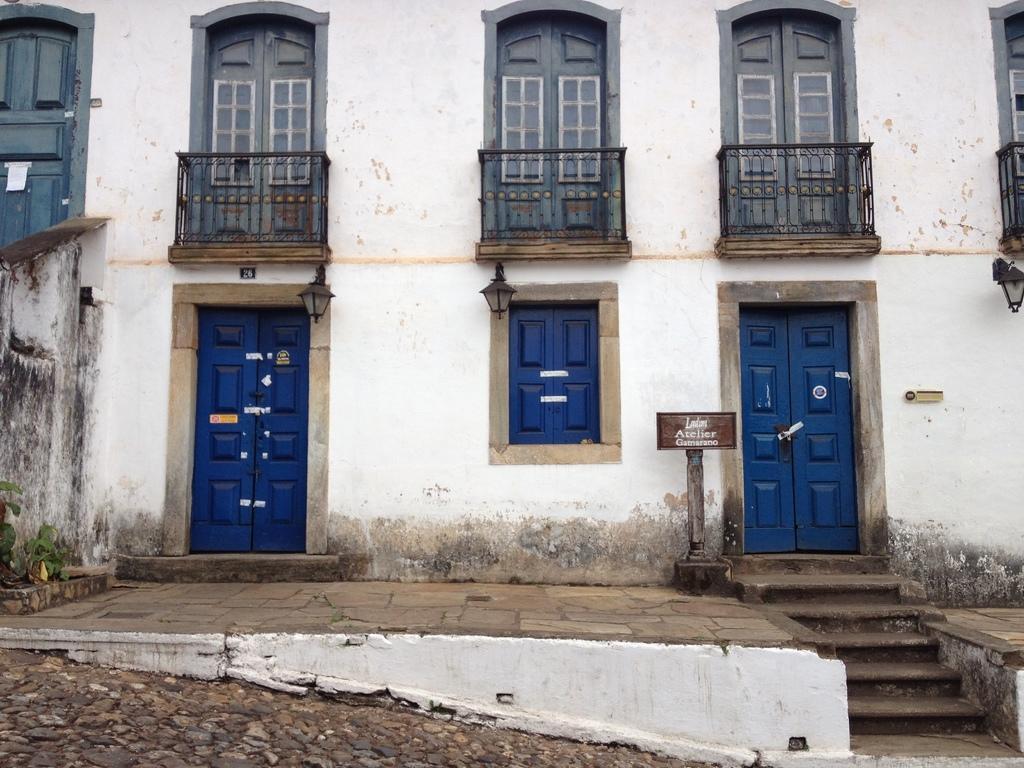Could you give a brief overview of what you see in this image? In this image on the right side, I can see a board with some text written on it. I can also see the stairs. In the background, I can see a building with doors and a window. 